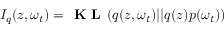Convert formula to latex. <formula><loc_0><loc_0><loc_500><loc_500>I _ { q } ( z , \omega _ { t } ) = K L ( q ( z , \omega _ { t } ) | | q ( z ) p ( \omega _ { t } ) )</formula> 